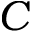<formula> <loc_0><loc_0><loc_500><loc_500>C</formula> 